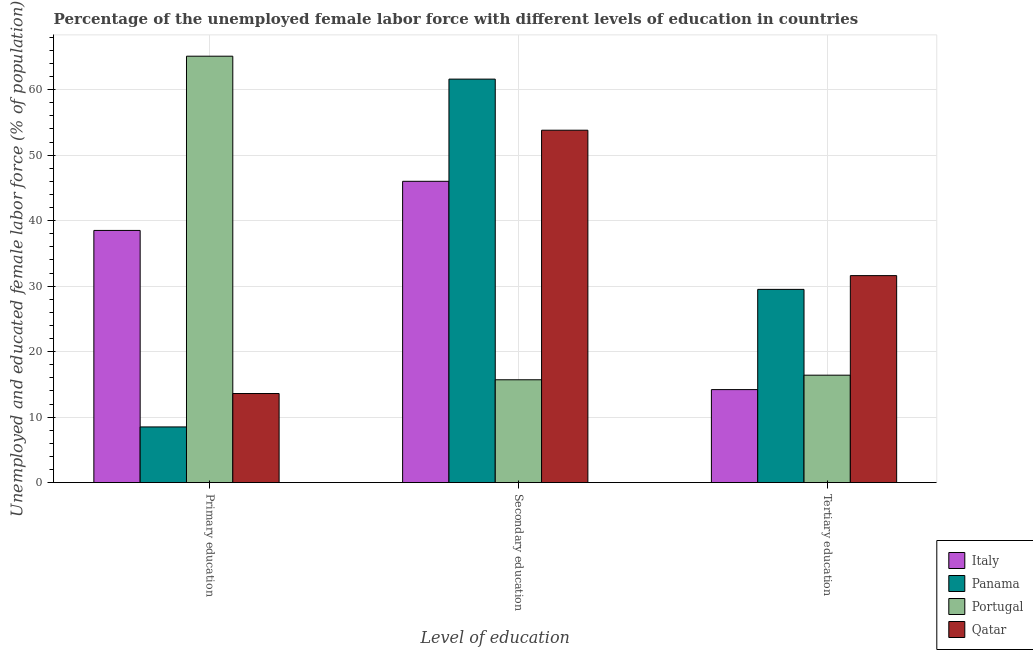How many different coloured bars are there?
Provide a short and direct response. 4. How many groups of bars are there?
Ensure brevity in your answer.  3. How many bars are there on the 2nd tick from the left?
Provide a short and direct response. 4. How many bars are there on the 1st tick from the right?
Provide a succinct answer. 4. What is the percentage of female labor force who received secondary education in Italy?
Provide a short and direct response. 46. Across all countries, what is the maximum percentage of female labor force who received tertiary education?
Make the answer very short. 31.6. In which country was the percentage of female labor force who received secondary education maximum?
Provide a succinct answer. Panama. In which country was the percentage of female labor force who received secondary education minimum?
Provide a short and direct response. Portugal. What is the total percentage of female labor force who received primary education in the graph?
Provide a succinct answer. 125.7. What is the difference between the percentage of female labor force who received tertiary education in Qatar and that in Italy?
Your answer should be compact. 17.4. What is the difference between the percentage of female labor force who received secondary education in Italy and the percentage of female labor force who received primary education in Portugal?
Provide a short and direct response. -19.1. What is the average percentage of female labor force who received primary education per country?
Your answer should be compact. 31.42. What is the difference between the percentage of female labor force who received secondary education and percentage of female labor force who received primary education in Portugal?
Offer a terse response. -49.4. In how many countries, is the percentage of female labor force who received primary education greater than 30 %?
Offer a terse response. 2. What is the ratio of the percentage of female labor force who received secondary education in Portugal to that in Panama?
Your answer should be compact. 0.25. Is the percentage of female labor force who received primary education in Panama less than that in Qatar?
Ensure brevity in your answer.  Yes. What is the difference between the highest and the second highest percentage of female labor force who received tertiary education?
Offer a terse response. 2.1. What is the difference between the highest and the lowest percentage of female labor force who received secondary education?
Your response must be concise. 45.9. In how many countries, is the percentage of female labor force who received primary education greater than the average percentage of female labor force who received primary education taken over all countries?
Your response must be concise. 2. Is the sum of the percentage of female labor force who received secondary education in Portugal and Panama greater than the maximum percentage of female labor force who received tertiary education across all countries?
Make the answer very short. Yes. What does the 1st bar from the right in Primary education represents?
Provide a succinct answer. Qatar. Is it the case that in every country, the sum of the percentage of female labor force who received primary education and percentage of female labor force who received secondary education is greater than the percentage of female labor force who received tertiary education?
Keep it short and to the point. Yes. How many bars are there?
Give a very brief answer. 12. How many countries are there in the graph?
Offer a terse response. 4. What is the difference between two consecutive major ticks on the Y-axis?
Provide a succinct answer. 10. Does the graph contain grids?
Give a very brief answer. Yes. How many legend labels are there?
Your answer should be very brief. 4. How are the legend labels stacked?
Ensure brevity in your answer.  Vertical. What is the title of the graph?
Your answer should be very brief. Percentage of the unemployed female labor force with different levels of education in countries. Does "Monaco" appear as one of the legend labels in the graph?
Offer a very short reply. No. What is the label or title of the X-axis?
Your answer should be very brief. Level of education. What is the label or title of the Y-axis?
Offer a very short reply. Unemployed and educated female labor force (% of population). What is the Unemployed and educated female labor force (% of population) in Italy in Primary education?
Offer a terse response. 38.5. What is the Unemployed and educated female labor force (% of population) in Portugal in Primary education?
Provide a short and direct response. 65.1. What is the Unemployed and educated female labor force (% of population) in Qatar in Primary education?
Make the answer very short. 13.6. What is the Unemployed and educated female labor force (% of population) in Panama in Secondary education?
Ensure brevity in your answer.  61.6. What is the Unemployed and educated female labor force (% of population) in Portugal in Secondary education?
Provide a succinct answer. 15.7. What is the Unemployed and educated female labor force (% of population) in Qatar in Secondary education?
Your answer should be very brief. 53.8. What is the Unemployed and educated female labor force (% of population) in Italy in Tertiary education?
Provide a short and direct response. 14.2. What is the Unemployed and educated female labor force (% of population) of Panama in Tertiary education?
Provide a short and direct response. 29.5. What is the Unemployed and educated female labor force (% of population) of Portugal in Tertiary education?
Keep it short and to the point. 16.4. What is the Unemployed and educated female labor force (% of population) of Qatar in Tertiary education?
Offer a very short reply. 31.6. Across all Level of education, what is the maximum Unemployed and educated female labor force (% of population) in Italy?
Your answer should be compact. 46. Across all Level of education, what is the maximum Unemployed and educated female labor force (% of population) of Panama?
Provide a succinct answer. 61.6. Across all Level of education, what is the maximum Unemployed and educated female labor force (% of population) in Portugal?
Your answer should be compact. 65.1. Across all Level of education, what is the maximum Unemployed and educated female labor force (% of population) of Qatar?
Ensure brevity in your answer.  53.8. Across all Level of education, what is the minimum Unemployed and educated female labor force (% of population) of Italy?
Ensure brevity in your answer.  14.2. Across all Level of education, what is the minimum Unemployed and educated female labor force (% of population) in Portugal?
Offer a terse response. 15.7. Across all Level of education, what is the minimum Unemployed and educated female labor force (% of population) in Qatar?
Your answer should be compact. 13.6. What is the total Unemployed and educated female labor force (% of population) of Italy in the graph?
Provide a short and direct response. 98.7. What is the total Unemployed and educated female labor force (% of population) of Panama in the graph?
Ensure brevity in your answer.  99.6. What is the total Unemployed and educated female labor force (% of population) of Portugal in the graph?
Your answer should be very brief. 97.2. What is the total Unemployed and educated female labor force (% of population) in Qatar in the graph?
Give a very brief answer. 99. What is the difference between the Unemployed and educated female labor force (% of population) in Italy in Primary education and that in Secondary education?
Keep it short and to the point. -7.5. What is the difference between the Unemployed and educated female labor force (% of population) of Panama in Primary education and that in Secondary education?
Your answer should be very brief. -53.1. What is the difference between the Unemployed and educated female labor force (% of population) in Portugal in Primary education and that in Secondary education?
Your answer should be compact. 49.4. What is the difference between the Unemployed and educated female labor force (% of population) in Qatar in Primary education and that in Secondary education?
Offer a very short reply. -40.2. What is the difference between the Unemployed and educated female labor force (% of population) of Italy in Primary education and that in Tertiary education?
Provide a short and direct response. 24.3. What is the difference between the Unemployed and educated female labor force (% of population) in Panama in Primary education and that in Tertiary education?
Provide a short and direct response. -21. What is the difference between the Unemployed and educated female labor force (% of population) in Portugal in Primary education and that in Tertiary education?
Your answer should be very brief. 48.7. What is the difference between the Unemployed and educated female labor force (% of population) in Italy in Secondary education and that in Tertiary education?
Offer a terse response. 31.8. What is the difference between the Unemployed and educated female labor force (% of population) of Panama in Secondary education and that in Tertiary education?
Provide a short and direct response. 32.1. What is the difference between the Unemployed and educated female labor force (% of population) of Italy in Primary education and the Unemployed and educated female labor force (% of population) of Panama in Secondary education?
Give a very brief answer. -23.1. What is the difference between the Unemployed and educated female labor force (% of population) of Italy in Primary education and the Unemployed and educated female labor force (% of population) of Portugal in Secondary education?
Give a very brief answer. 22.8. What is the difference between the Unemployed and educated female labor force (% of population) in Italy in Primary education and the Unemployed and educated female labor force (% of population) in Qatar in Secondary education?
Offer a terse response. -15.3. What is the difference between the Unemployed and educated female labor force (% of population) of Panama in Primary education and the Unemployed and educated female labor force (% of population) of Portugal in Secondary education?
Offer a terse response. -7.2. What is the difference between the Unemployed and educated female labor force (% of population) in Panama in Primary education and the Unemployed and educated female labor force (% of population) in Qatar in Secondary education?
Ensure brevity in your answer.  -45.3. What is the difference between the Unemployed and educated female labor force (% of population) of Italy in Primary education and the Unemployed and educated female labor force (% of population) of Portugal in Tertiary education?
Your answer should be compact. 22.1. What is the difference between the Unemployed and educated female labor force (% of population) of Panama in Primary education and the Unemployed and educated female labor force (% of population) of Portugal in Tertiary education?
Offer a very short reply. -7.9. What is the difference between the Unemployed and educated female labor force (% of population) in Panama in Primary education and the Unemployed and educated female labor force (% of population) in Qatar in Tertiary education?
Your answer should be compact. -23.1. What is the difference between the Unemployed and educated female labor force (% of population) of Portugal in Primary education and the Unemployed and educated female labor force (% of population) of Qatar in Tertiary education?
Keep it short and to the point. 33.5. What is the difference between the Unemployed and educated female labor force (% of population) of Italy in Secondary education and the Unemployed and educated female labor force (% of population) of Portugal in Tertiary education?
Provide a short and direct response. 29.6. What is the difference between the Unemployed and educated female labor force (% of population) of Italy in Secondary education and the Unemployed and educated female labor force (% of population) of Qatar in Tertiary education?
Offer a terse response. 14.4. What is the difference between the Unemployed and educated female labor force (% of population) in Panama in Secondary education and the Unemployed and educated female labor force (% of population) in Portugal in Tertiary education?
Offer a very short reply. 45.2. What is the difference between the Unemployed and educated female labor force (% of population) of Panama in Secondary education and the Unemployed and educated female labor force (% of population) of Qatar in Tertiary education?
Make the answer very short. 30. What is the difference between the Unemployed and educated female labor force (% of population) in Portugal in Secondary education and the Unemployed and educated female labor force (% of population) in Qatar in Tertiary education?
Ensure brevity in your answer.  -15.9. What is the average Unemployed and educated female labor force (% of population) in Italy per Level of education?
Provide a succinct answer. 32.9. What is the average Unemployed and educated female labor force (% of population) of Panama per Level of education?
Provide a succinct answer. 33.2. What is the average Unemployed and educated female labor force (% of population) of Portugal per Level of education?
Your answer should be very brief. 32.4. What is the average Unemployed and educated female labor force (% of population) in Qatar per Level of education?
Give a very brief answer. 33. What is the difference between the Unemployed and educated female labor force (% of population) in Italy and Unemployed and educated female labor force (% of population) in Panama in Primary education?
Your answer should be compact. 30. What is the difference between the Unemployed and educated female labor force (% of population) of Italy and Unemployed and educated female labor force (% of population) of Portugal in Primary education?
Your answer should be compact. -26.6. What is the difference between the Unemployed and educated female labor force (% of population) of Italy and Unemployed and educated female labor force (% of population) of Qatar in Primary education?
Your answer should be very brief. 24.9. What is the difference between the Unemployed and educated female labor force (% of population) of Panama and Unemployed and educated female labor force (% of population) of Portugal in Primary education?
Your answer should be compact. -56.6. What is the difference between the Unemployed and educated female labor force (% of population) of Panama and Unemployed and educated female labor force (% of population) of Qatar in Primary education?
Give a very brief answer. -5.1. What is the difference between the Unemployed and educated female labor force (% of population) of Portugal and Unemployed and educated female labor force (% of population) of Qatar in Primary education?
Make the answer very short. 51.5. What is the difference between the Unemployed and educated female labor force (% of population) of Italy and Unemployed and educated female labor force (% of population) of Panama in Secondary education?
Ensure brevity in your answer.  -15.6. What is the difference between the Unemployed and educated female labor force (% of population) in Italy and Unemployed and educated female labor force (% of population) in Portugal in Secondary education?
Make the answer very short. 30.3. What is the difference between the Unemployed and educated female labor force (% of population) of Panama and Unemployed and educated female labor force (% of population) of Portugal in Secondary education?
Your answer should be very brief. 45.9. What is the difference between the Unemployed and educated female labor force (% of population) in Panama and Unemployed and educated female labor force (% of population) in Qatar in Secondary education?
Your answer should be compact. 7.8. What is the difference between the Unemployed and educated female labor force (% of population) of Portugal and Unemployed and educated female labor force (% of population) of Qatar in Secondary education?
Offer a very short reply. -38.1. What is the difference between the Unemployed and educated female labor force (% of population) of Italy and Unemployed and educated female labor force (% of population) of Panama in Tertiary education?
Provide a short and direct response. -15.3. What is the difference between the Unemployed and educated female labor force (% of population) in Italy and Unemployed and educated female labor force (% of population) in Qatar in Tertiary education?
Provide a short and direct response. -17.4. What is the difference between the Unemployed and educated female labor force (% of population) in Panama and Unemployed and educated female labor force (% of population) in Portugal in Tertiary education?
Offer a terse response. 13.1. What is the difference between the Unemployed and educated female labor force (% of population) in Portugal and Unemployed and educated female labor force (% of population) in Qatar in Tertiary education?
Keep it short and to the point. -15.2. What is the ratio of the Unemployed and educated female labor force (% of population) of Italy in Primary education to that in Secondary education?
Your response must be concise. 0.84. What is the ratio of the Unemployed and educated female labor force (% of population) in Panama in Primary education to that in Secondary education?
Provide a short and direct response. 0.14. What is the ratio of the Unemployed and educated female labor force (% of population) in Portugal in Primary education to that in Secondary education?
Your answer should be very brief. 4.15. What is the ratio of the Unemployed and educated female labor force (% of population) of Qatar in Primary education to that in Secondary education?
Your answer should be compact. 0.25. What is the ratio of the Unemployed and educated female labor force (% of population) in Italy in Primary education to that in Tertiary education?
Your answer should be compact. 2.71. What is the ratio of the Unemployed and educated female labor force (% of population) in Panama in Primary education to that in Tertiary education?
Your answer should be compact. 0.29. What is the ratio of the Unemployed and educated female labor force (% of population) in Portugal in Primary education to that in Tertiary education?
Provide a short and direct response. 3.97. What is the ratio of the Unemployed and educated female labor force (% of population) of Qatar in Primary education to that in Tertiary education?
Provide a short and direct response. 0.43. What is the ratio of the Unemployed and educated female labor force (% of population) in Italy in Secondary education to that in Tertiary education?
Your response must be concise. 3.24. What is the ratio of the Unemployed and educated female labor force (% of population) in Panama in Secondary education to that in Tertiary education?
Offer a terse response. 2.09. What is the ratio of the Unemployed and educated female labor force (% of population) of Portugal in Secondary education to that in Tertiary education?
Your response must be concise. 0.96. What is the ratio of the Unemployed and educated female labor force (% of population) of Qatar in Secondary education to that in Tertiary education?
Your answer should be very brief. 1.7. What is the difference between the highest and the second highest Unemployed and educated female labor force (% of population) of Panama?
Give a very brief answer. 32.1. What is the difference between the highest and the second highest Unemployed and educated female labor force (% of population) of Portugal?
Offer a terse response. 48.7. What is the difference between the highest and the second highest Unemployed and educated female labor force (% of population) in Qatar?
Your response must be concise. 22.2. What is the difference between the highest and the lowest Unemployed and educated female labor force (% of population) of Italy?
Offer a terse response. 31.8. What is the difference between the highest and the lowest Unemployed and educated female labor force (% of population) in Panama?
Your response must be concise. 53.1. What is the difference between the highest and the lowest Unemployed and educated female labor force (% of population) in Portugal?
Provide a short and direct response. 49.4. What is the difference between the highest and the lowest Unemployed and educated female labor force (% of population) in Qatar?
Give a very brief answer. 40.2. 